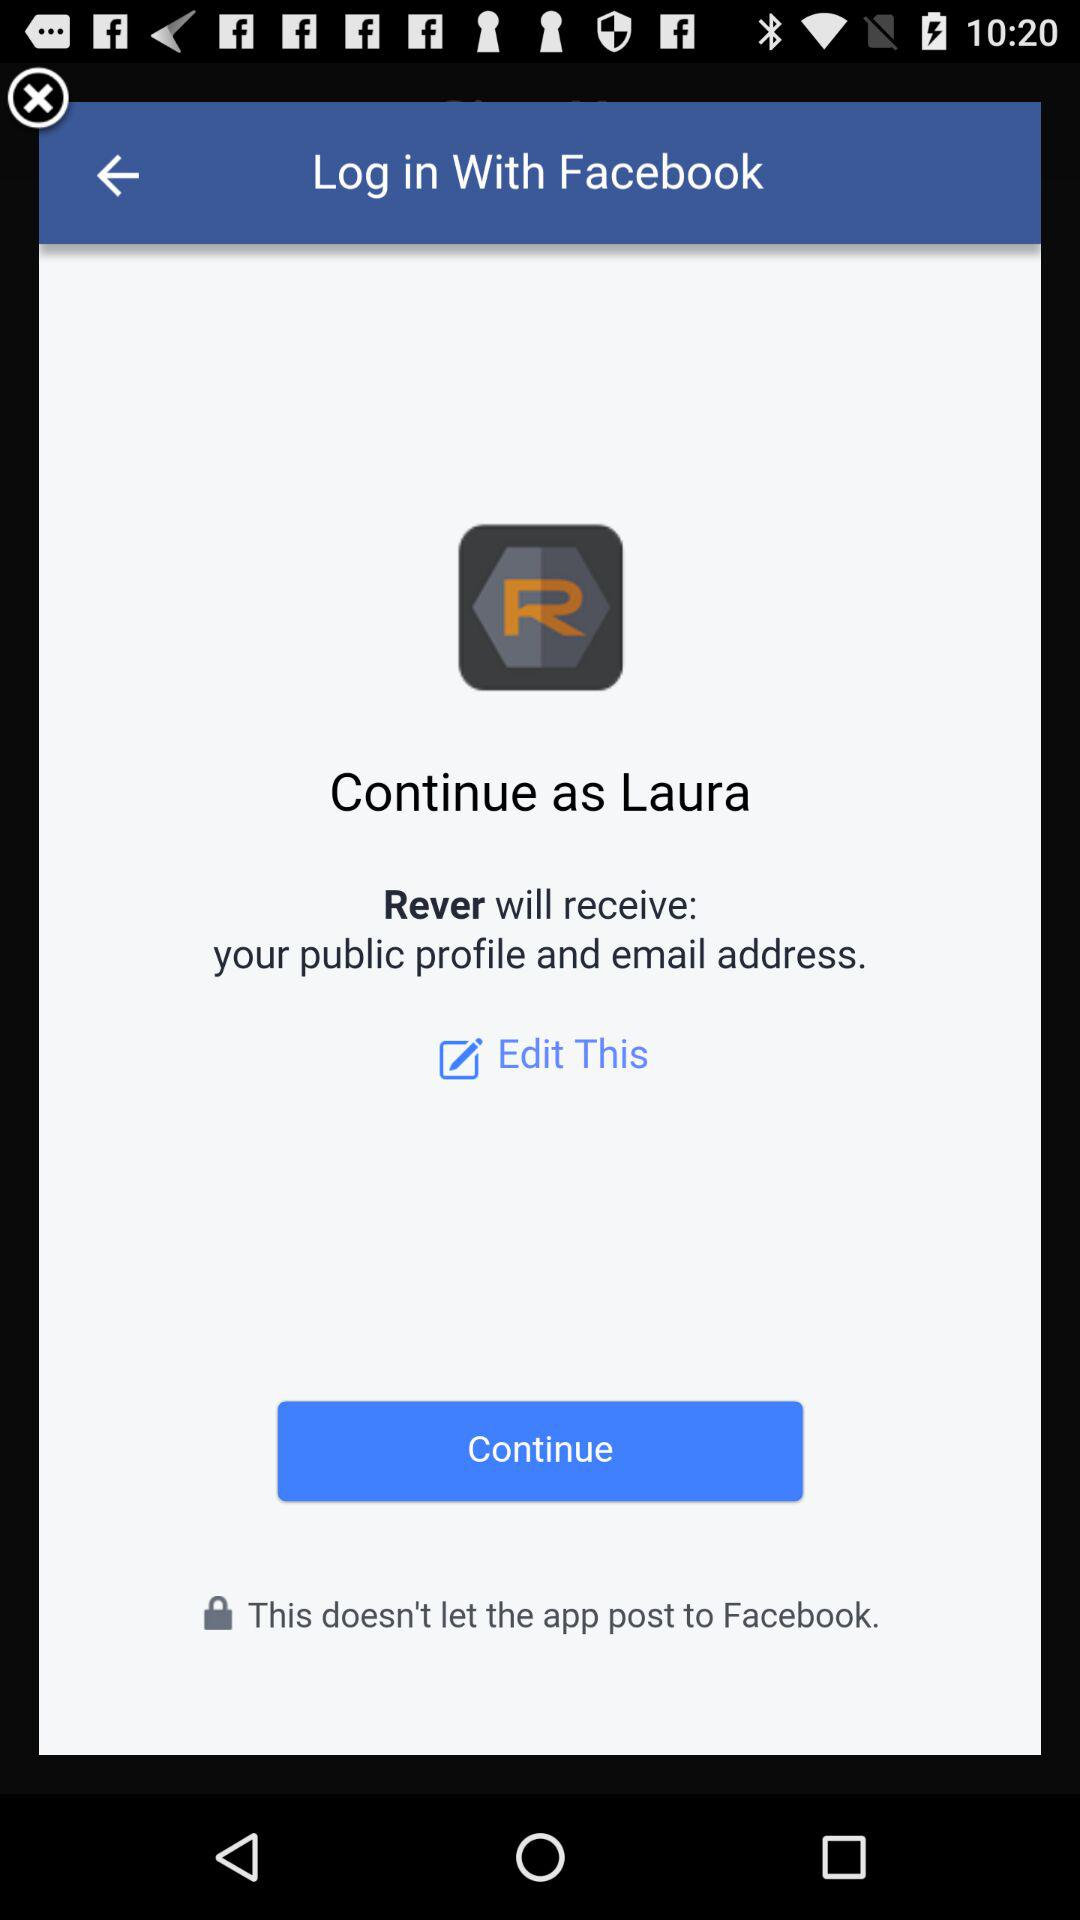What is the name of the user? The name of the user is "Laura". 